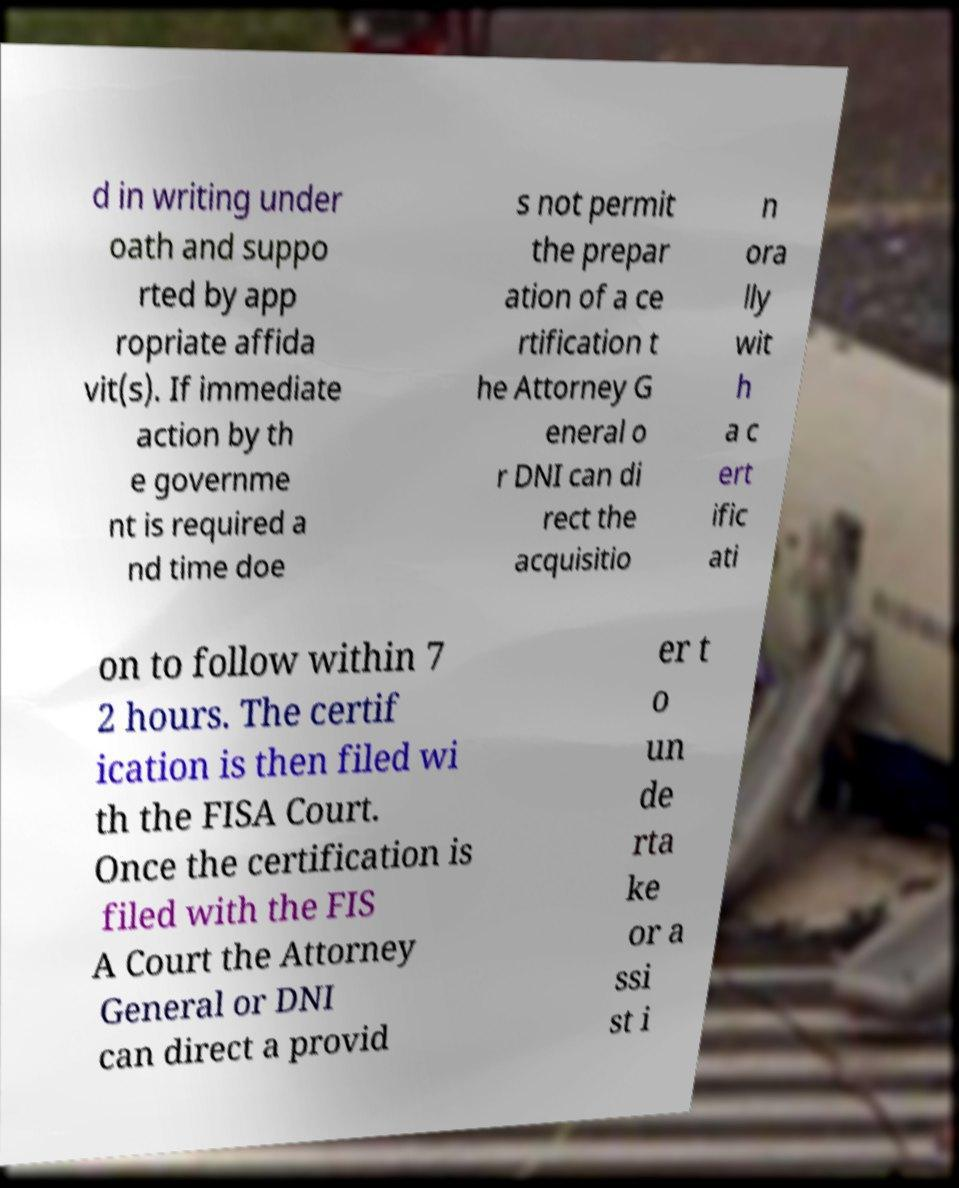Please identify and transcribe the text found in this image. d in writing under oath and suppo rted by app ropriate affida vit(s). If immediate action by th e governme nt is required a nd time doe s not permit the prepar ation of a ce rtification t he Attorney G eneral o r DNI can di rect the acquisitio n ora lly wit h a c ert ific ati on to follow within 7 2 hours. The certif ication is then filed wi th the FISA Court. Once the certification is filed with the FIS A Court the Attorney General or DNI can direct a provid er t o un de rta ke or a ssi st i 